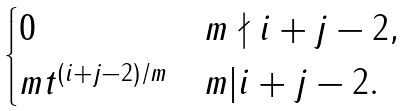Convert formula to latex. <formula><loc_0><loc_0><loc_500><loc_500>\begin{cases} 0 & m \nmid i + j - 2 , \\ m t ^ { ( i + j - 2 ) / m } & m | i + j - 2 . \end{cases}</formula> 